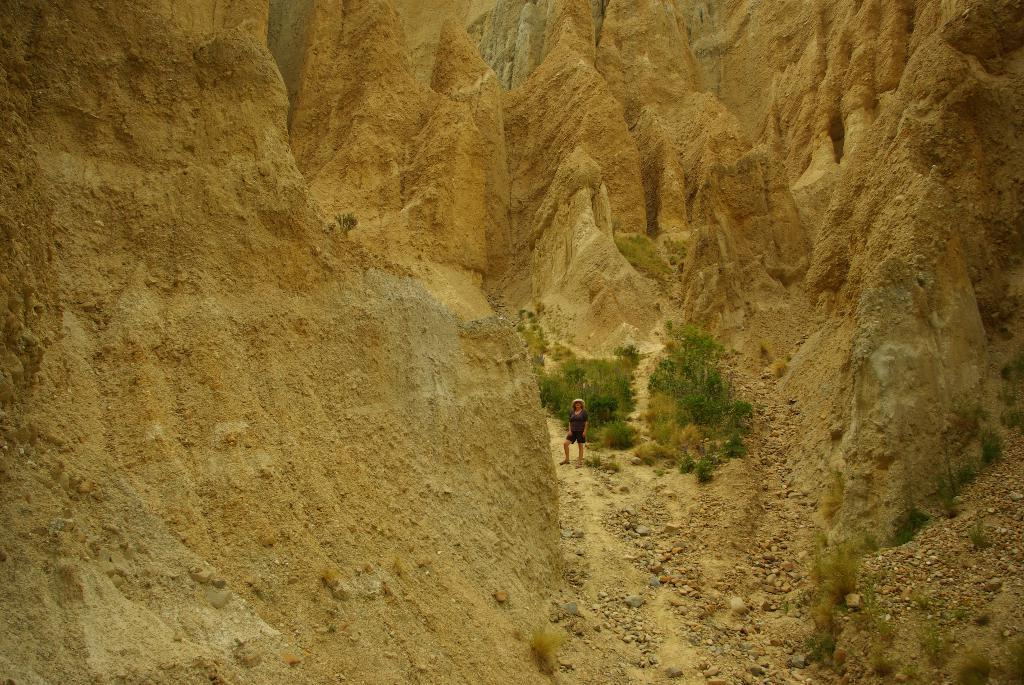What type of natural landform can be seen in the image? There are mountains in the image. What type of vegetation is present in the image? There are trees in the image. What type of terrain is visible in the image? Small stones and sand are present in the image. Is there any human presence in the image? Yes, there is a person standing in the image. What type of card is being used by the person in the image? There is no card present in the image. Can you describe the person's breathing pattern in the image? There is no information about the person's breathing pattern in the image. 